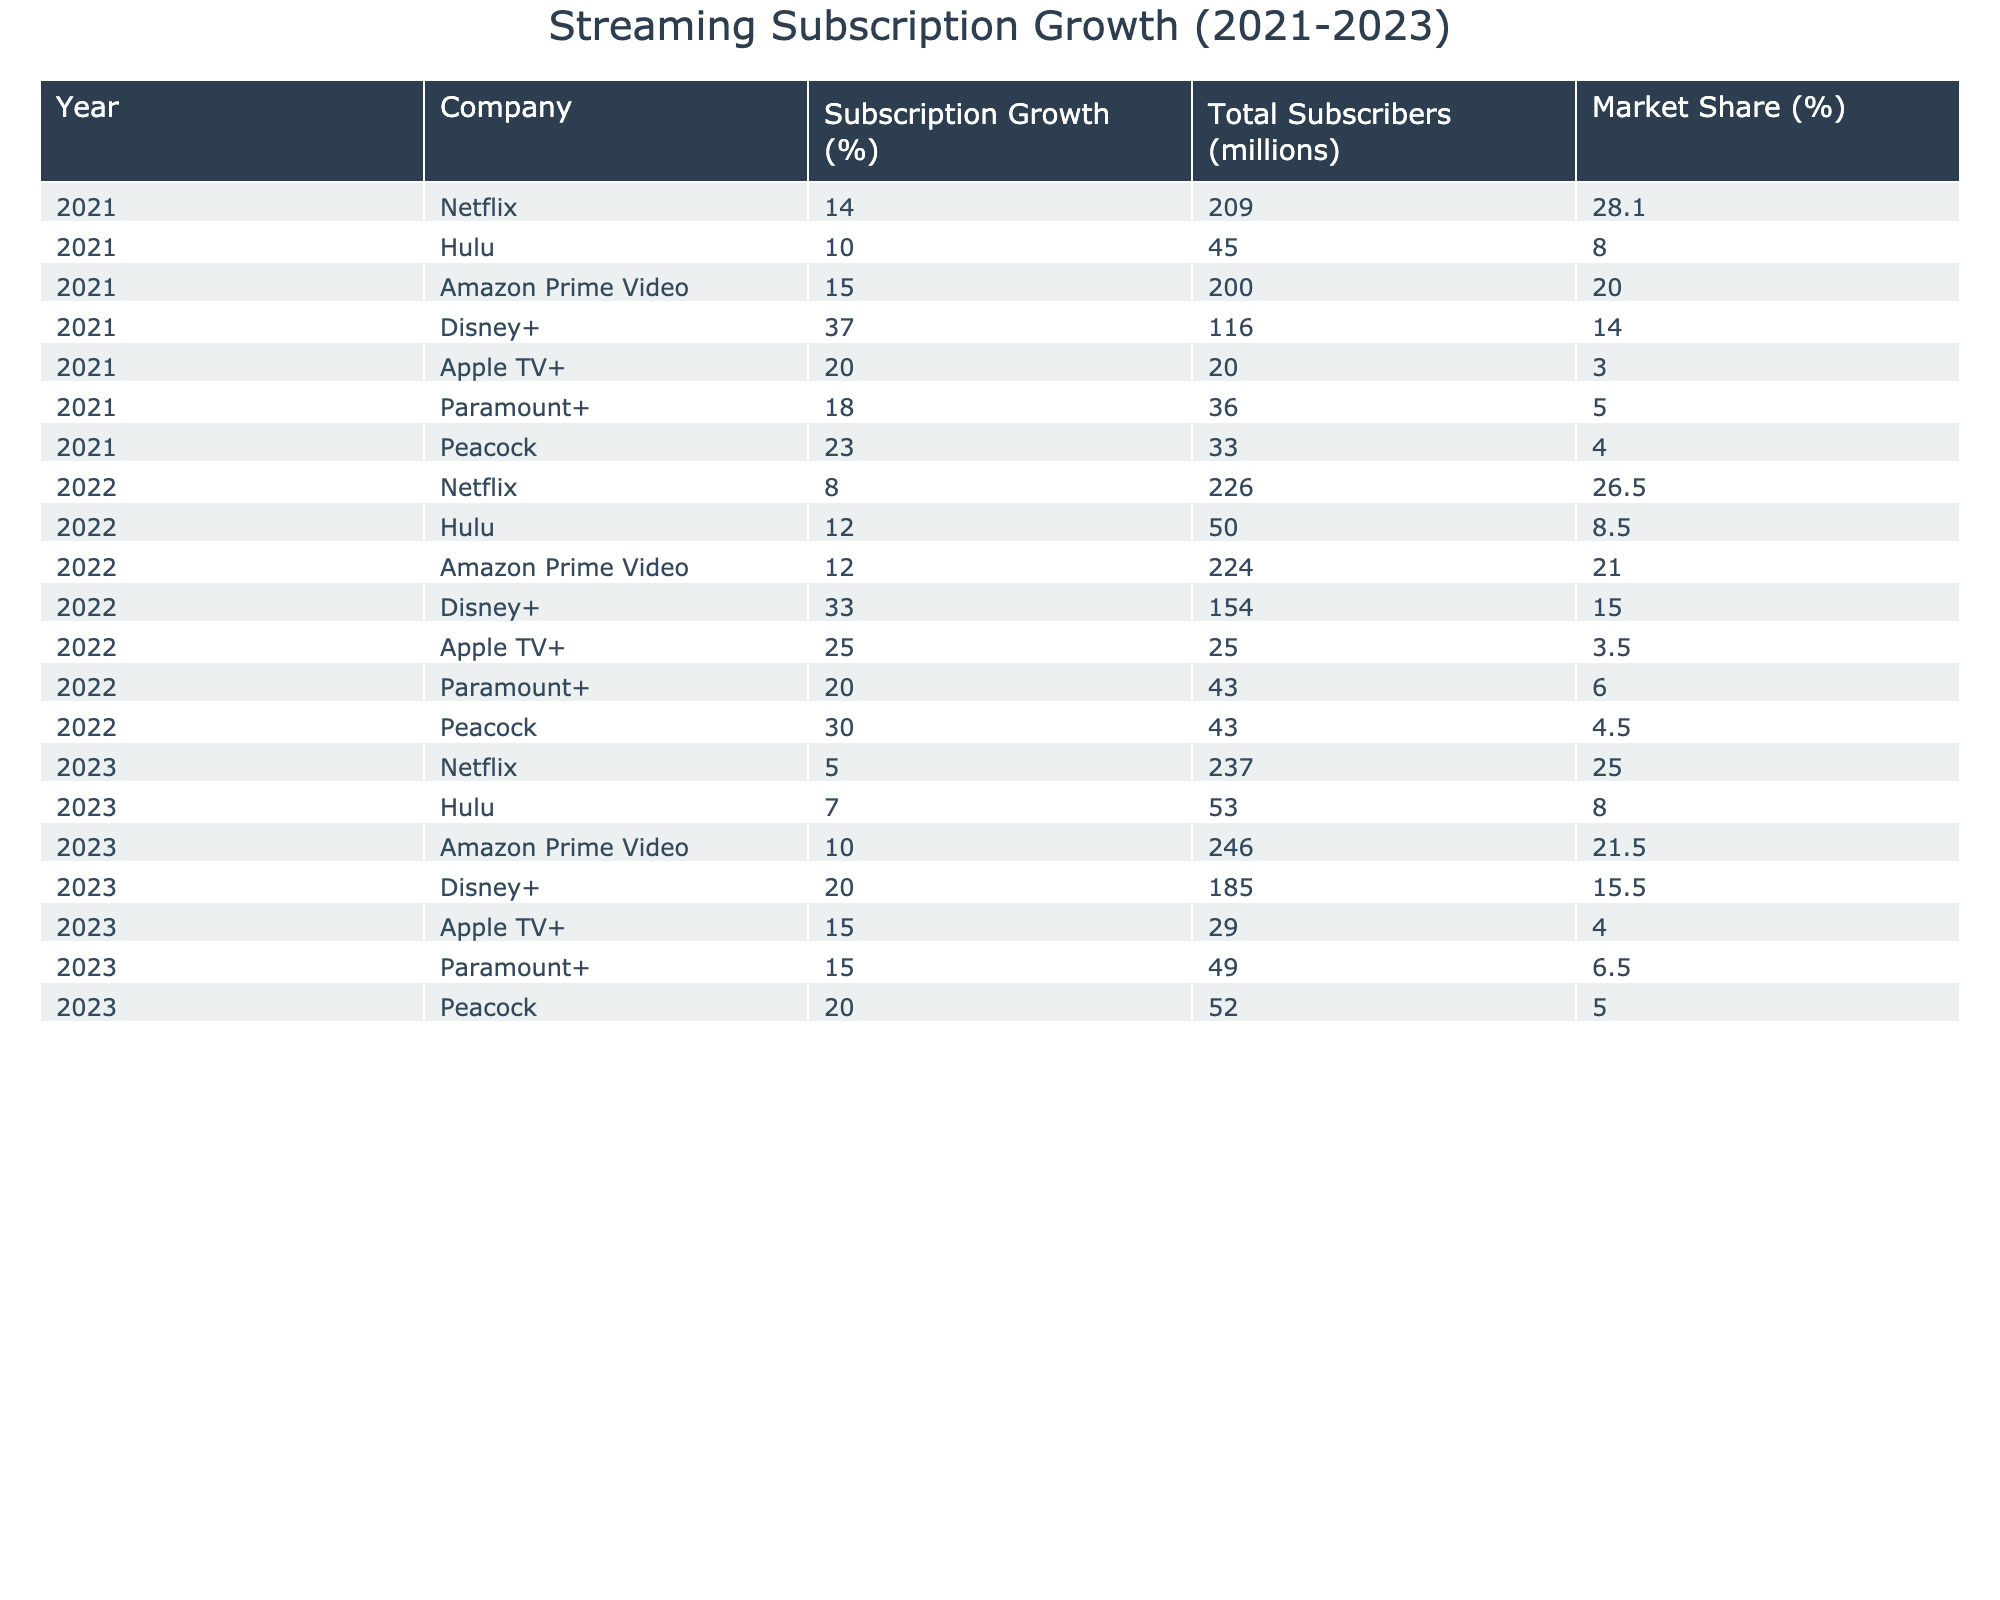What was the total number of subscribers for Hulu in 2023? Referring to the table, the total number of subscribers for Hulu in 2023 is clearly stated as 53 million.
Answer: 53 million Which company had the highest subscription growth percentage in 2022? By looking at the Subscription Growth (%) column for the year 2022, Disney+ has the highest percentage at 33%.
Answer: Disney+ What is the market share of Amazon Prime Video in 2021? The table indicates that the market share of Amazon Prime Video in 2021 is 20.0%.
Answer: 20.0% What is the difference in total subscribers for Netflix from 2021 to 2023? In 2021, Netflix had 209 million subscribers, and in 2023 it had 237 million. The difference is 237 - 209 = 28 million.
Answer: 28 million Which streaming service consistently showed a growth in total subscribers from 2021 to 2023? By reviewing the total subscribers for each service over the three years, all the companies show an increase except Netflix, which showed a decrease in market share despite total subscriber growth.
Answer: All companies (except Netflix) showed consistent growth Was there any decline in the subscription growth percentage for any company from 2021 to 2023? Yes, Netflix's subscription growth percentage declined from 14.0% in 2021 to 5.0% in 2023, showing a decrease.
Answer: Yes What was the average market share of Disney+ from 2021 to 2023? The market shares for Disney+ over three years are: 14.0%, 15.0%, and 15.5%. The average is calculated as (14.0 + 15.0 + 15.5) / 3 = 14.5%.
Answer: 14.5% Which company had the lowest subscription growth in 2021? In the year 2021, the lowest subscription growth percentage is found under Apple TV+ at 20.0%.
Answer: Apple TV+ Compare the market share of Paramount+ in 2021 and 2023. In 2021, Paramount+ had a market share of 5.0%, while in 2023 it increased to 6.5%. This shows an increase of 1%.
Answer: Increased by 1% What is the overall trend in subscription growth for Hulu based on the data from 2021 to 2023? By examining the subscription growth percentages: 10.0% in 2021, 12.0% in 2022, and 7.0% in 2023, the trend shows an initial increase followed by a decline.
Answer: Initial increase then decline 